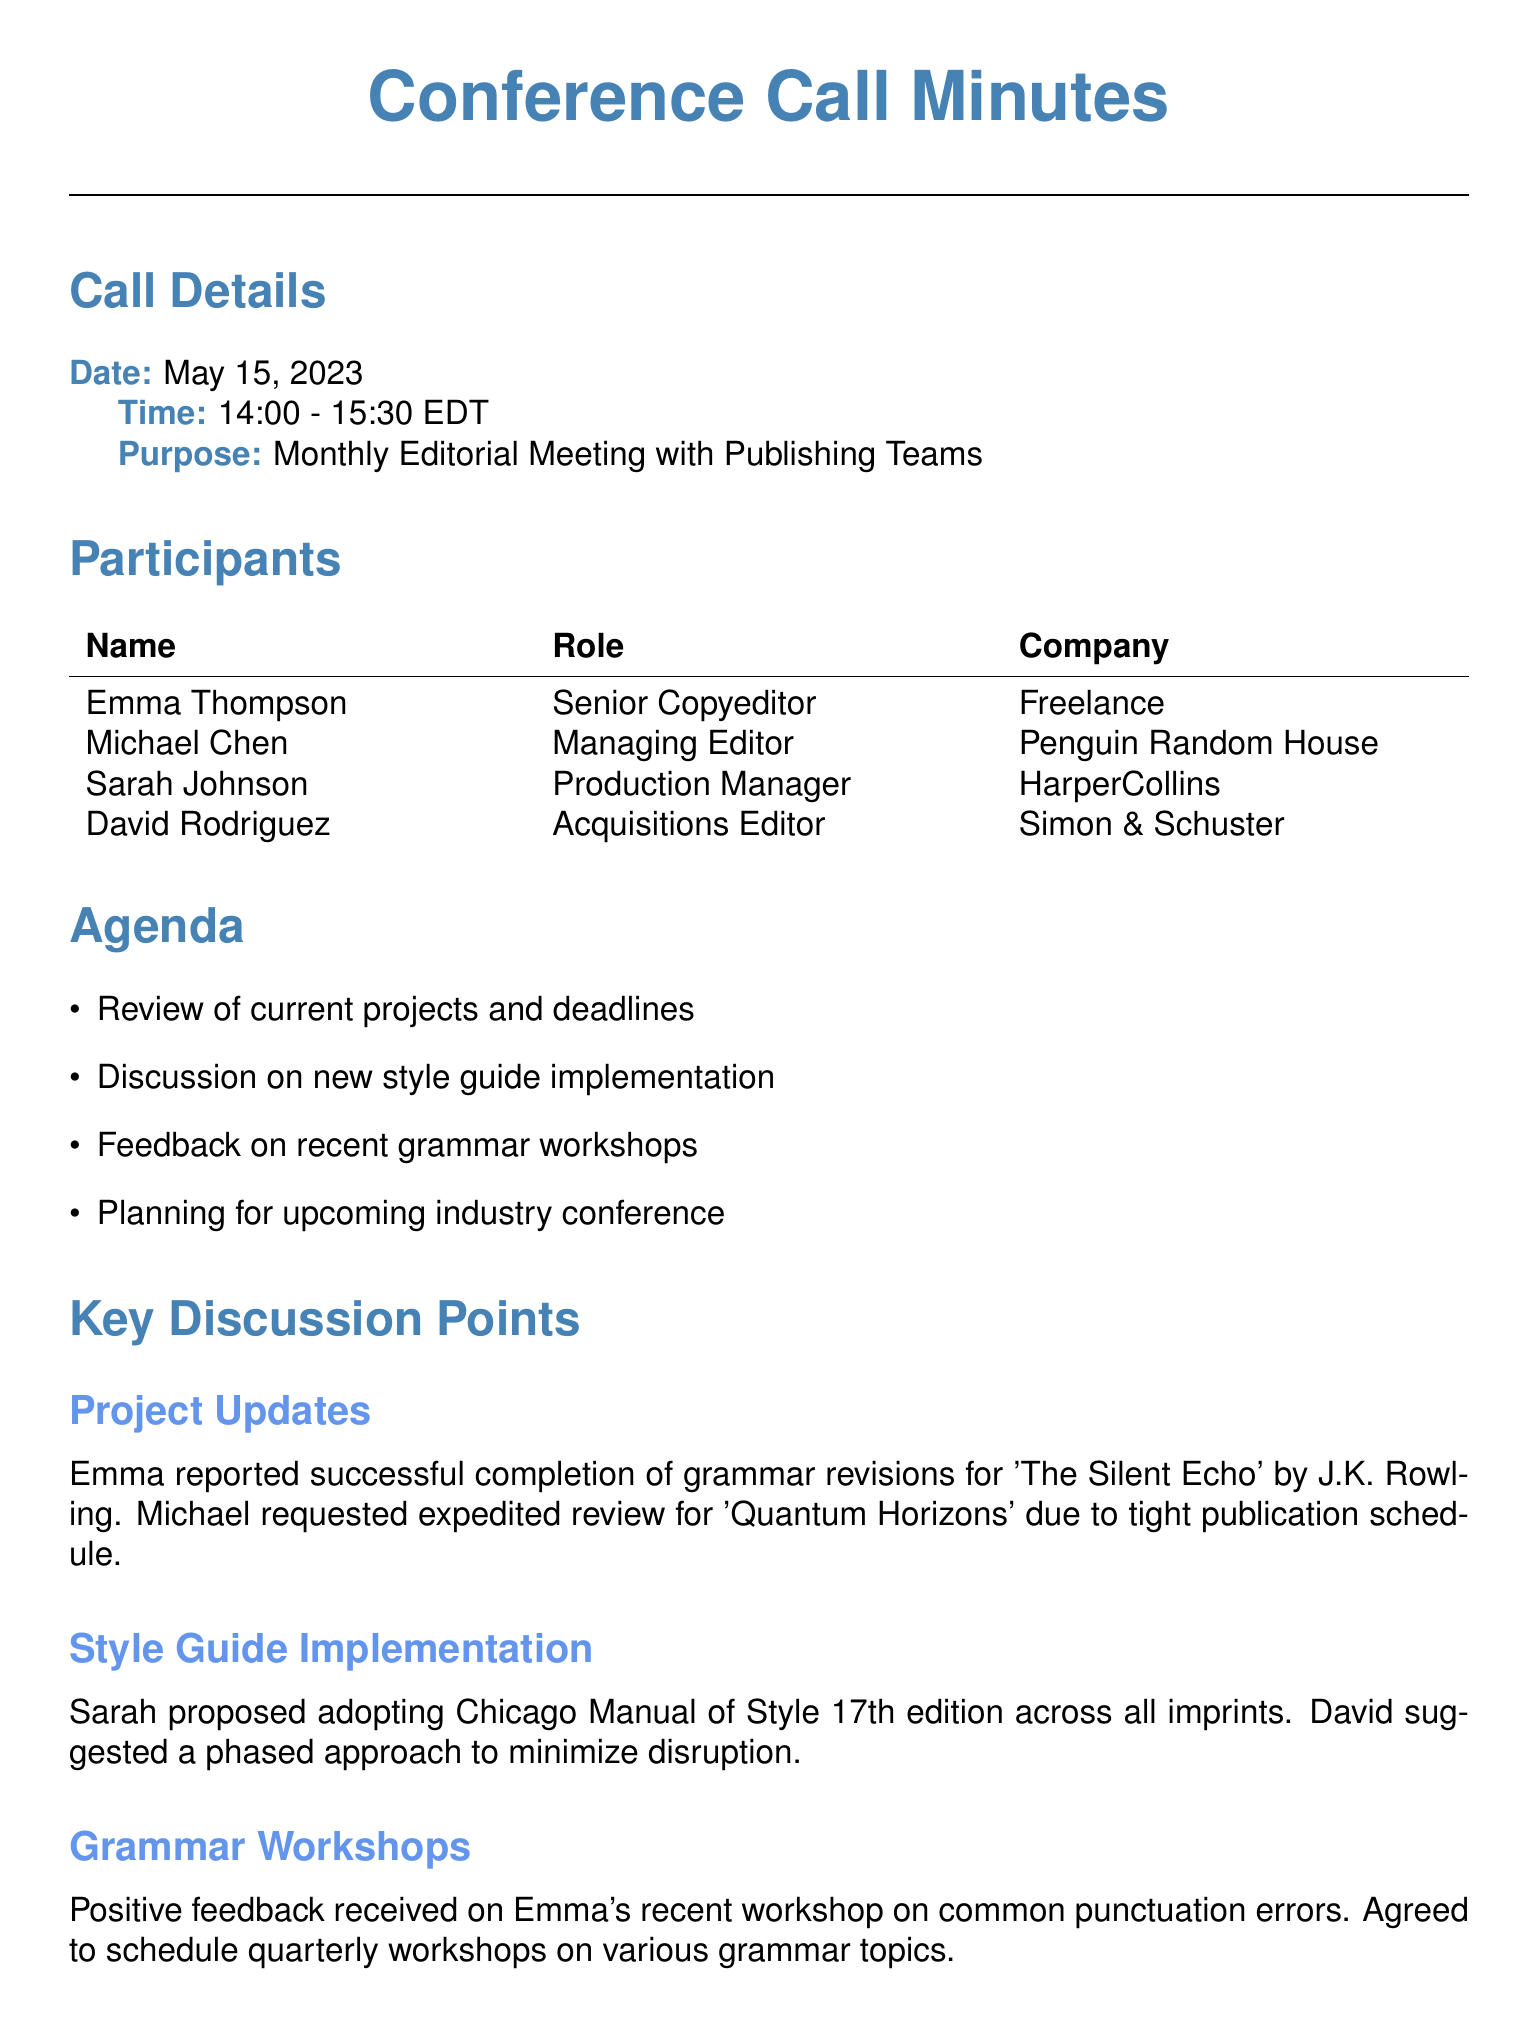What is the date of the conference call? The date is stated in the call details section of the document.
Answer: May 15, 2023 Who proposed the adoption of the Chicago Manual of Style? The proposal for the style guide implementation was made by Sarah Johnson in the discussion points section.
Answer: Sarah Johnson What is the purpose of the call? The purpose is outlined in the call details at the beginning of the document.
Answer: Monthly Editorial Meeting with Publishing Teams When is the next meeting scheduled? The next meeting date is explicitly mentioned at the end of the document.
Answer: June 19, 2023 What project did Emma report on during the meeting? The project discussed by Emma in the project updates section is noted in detail.
Answer: The Silent Echo How many action items were assigned during the call? The number of action items can be counted from the action items section.
Answer: Four What feedback was received on the grammar workshops? The feedback is mentioned in the context of the grammar workshops discussion.
Answer: Positive feedback Who is scheduled to present at the ACES conference? The person responsible for the presentation at the conference is specified in the industry conference section.
Answer: Emma 